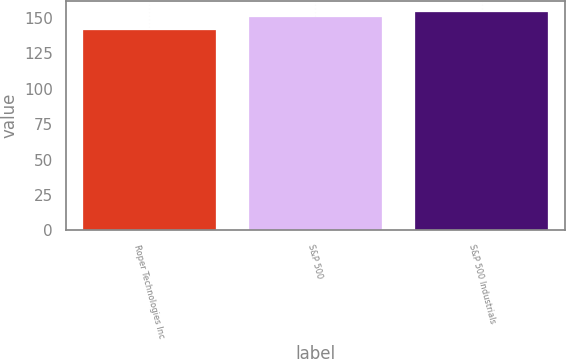Convert chart to OTSL. <chart><loc_0><loc_0><loc_500><loc_500><bar_chart><fcel>Roper Technologies Inc<fcel>S&P 500<fcel>S&P 500 Industrials<nl><fcel>141.61<fcel>150.51<fcel>154.5<nl></chart> 